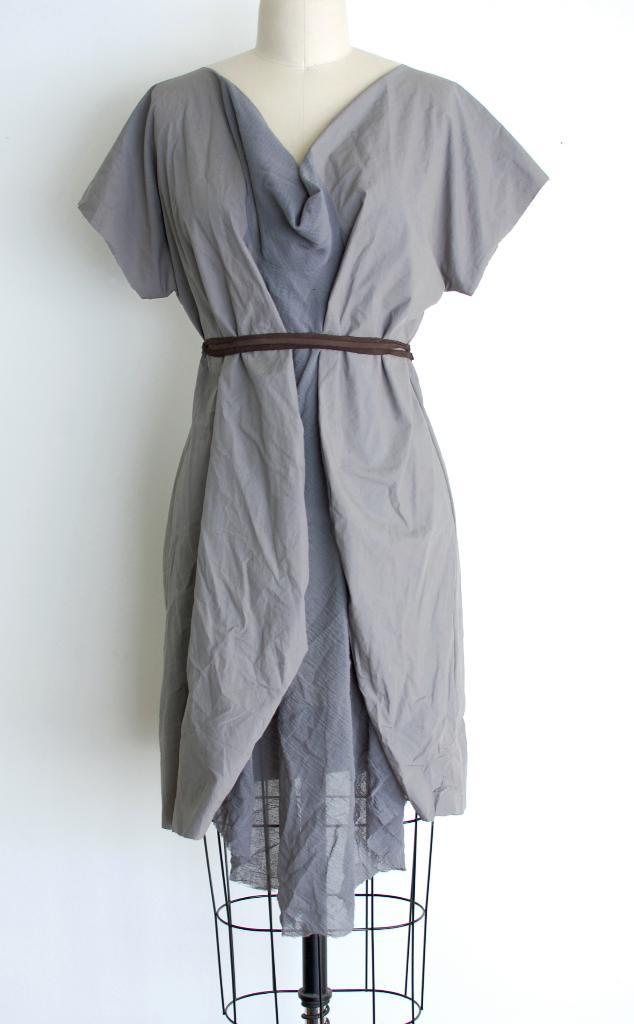What is the main subject of the image? There is a mannequin in the image. What is the mannequin wearing? The mannequin is wearing a dress. What color is the background of the image? The background of the image is white. What type of instrument is the mannequin playing in the image? There is no instrument present in the image, as the mannequin is simply wearing a dress. 